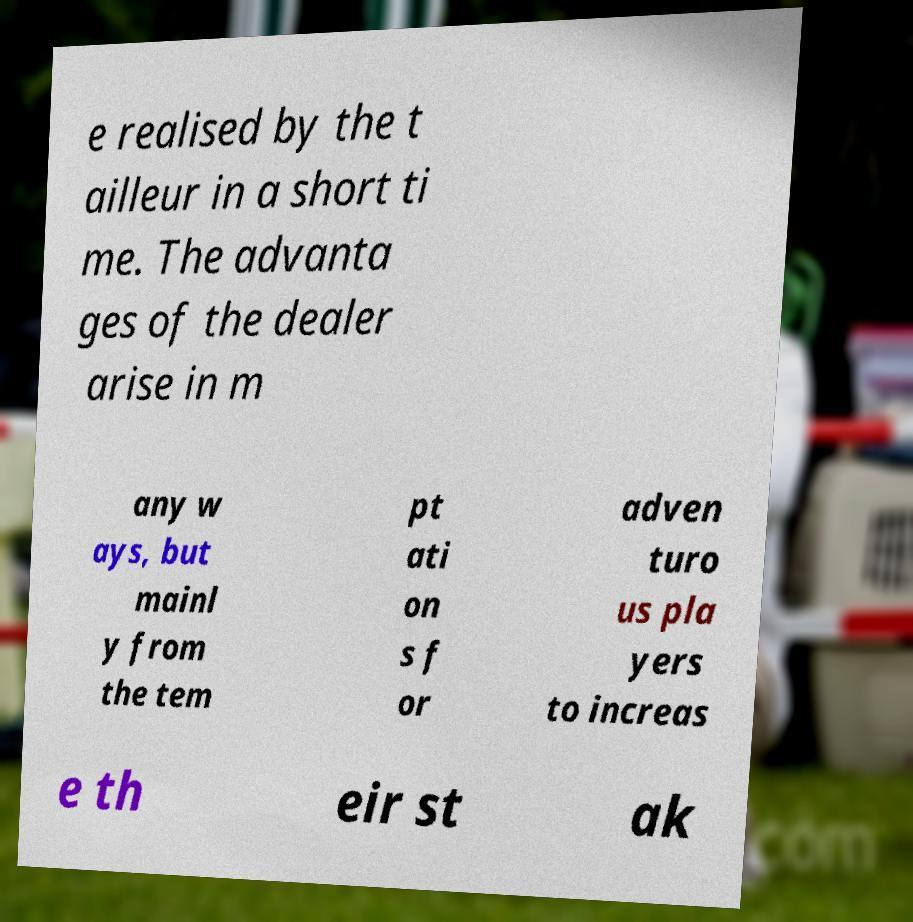Could you extract and type out the text from this image? e realised by the t ailleur in a short ti me. The advanta ges of the dealer arise in m any w ays, but mainl y from the tem pt ati on s f or adven turo us pla yers to increas e th eir st ak 